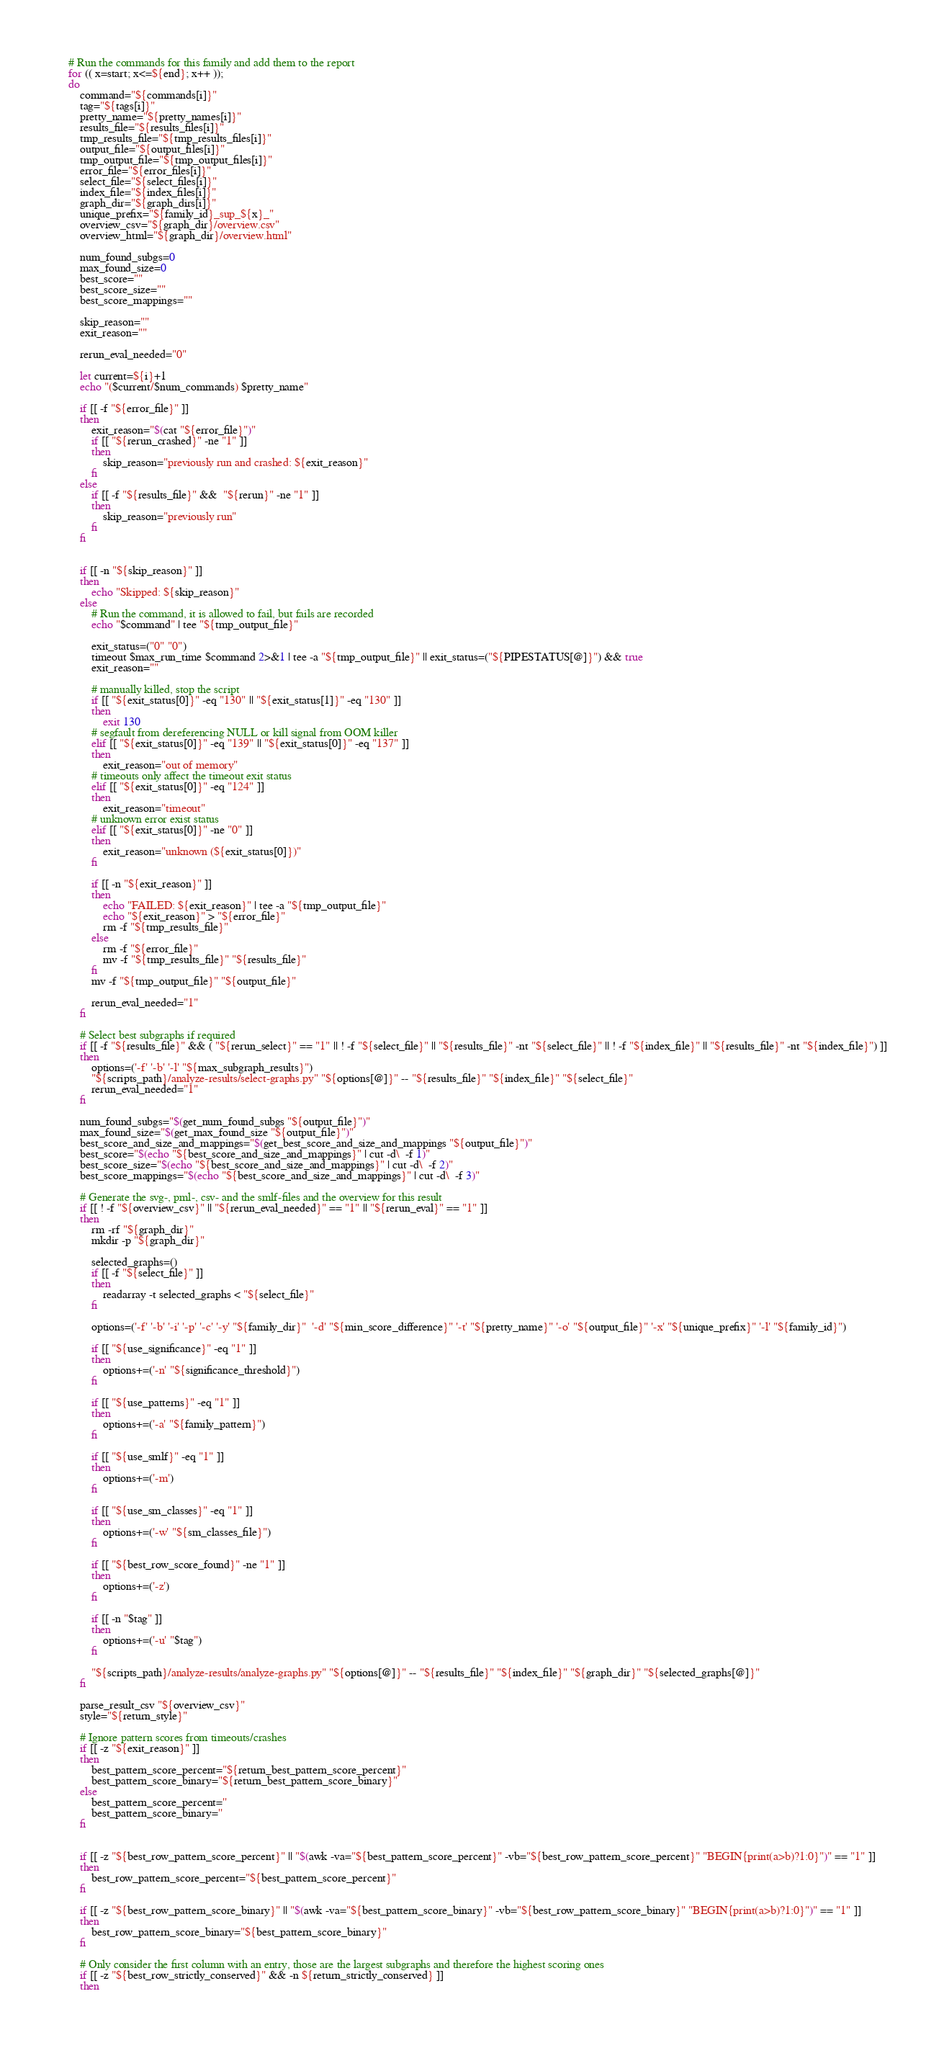Convert code to text. <code><loc_0><loc_0><loc_500><loc_500><_Bash_>    # Run the commands for this family and add them to the report
    for (( x=start; x<=${end}; x++ ));
    do
        command="${commands[i]}"
        tag="${tags[i]}"
        pretty_name="${pretty_names[i]}"
        results_file="${results_files[i]}"
        tmp_results_file="${tmp_results_files[i]}"
        output_file="${output_files[i]}"
        tmp_output_file="${tmp_output_files[i]}"
        error_file="${error_files[i]}"
        select_file="${select_files[i]}"
        index_file="${index_files[i]}"
        graph_dir="${graph_dirs[i]}"
        unique_prefix="${family_id}_sup_${x}_"
        overview_csv="${graph_dir}/overview.csv"
        overview_html="${graph_dir}/overview.html"

        num_found_subgs=0
        max_found_size=0
        best_score=""
        best_score_size=""
        best_score_mappings=""

        skip_reason=""
        exit_reason=""

        rerun_eval_needed="0"

        let current=${i}+1
        echo "($current/$num_commands) $pretty_name"

        if [[ -f "${error_file}" ]]
        then
            exit_reason="$(cat "${error_file}")"
            if [[ "${rerun_crashed}" -ne "1" ]]
            then
                skip_reason="previously run and crashed: ${exit_reason}"
            fi
        else
            if [[ -f "${results_file}" &&  "${rerun}" -ne "1" ]]
            then
                skip_reason="previously run"
            fi
        fi


        if [[ -n "${skip_reason}" ]]
        then
            echo "Skipped: ${skip_reason}"
        else
            # Run the command, it is allowed to fail, but fails are recorded
            echo "$command" | tee "${tmp_output_file}"

            exit_status=("0" "0")
            timeout $max_run_time $command 2>&1 | tee -a "${tmp_output_file}" || exit_status=("${PIPESTATUS[@]}") && true
            exit_reason=""

            # manually killed, stop the script        
            if [[ "${exit_status[0]}" -eq "130" || "${exit_status[1]}" -eq "130" ]]
            then
                exit 130
            # segfault from dereferencing NULL or kill signal from OOM killer
            elif [[ "${exit_status[0]}" -eq "139" || "${exit_status[0]}" -eq "137" ]]
            then
                exit_reason="out of memory"
            # timeouts only affect the timeout exit status
            elif [[ "${exit_status[0]}" -eq "124" ]]
            then
                exit_reason="timeout"
            # unknown error exist status
            elif [[ "${exit_status[0]}" -ne "0" ]]
            then
                exit_reason="unknown (${exit_status[0]})"
            fi

            if [[ -n "${exit_reason}" ]]
            then
                echo "FAILED: ${exit_reason}" | tee -a "${tmp_output_file}"
                echo "${exit_reason}" > "${error_file}"
                rm -f "${tmp_results_file}"
            else
                rm -f "${error_file}"
                mv -f "${tmp_results_file}" "${results_file}"
            fi
            mv -f "${tmp_output_file}" "${output_file}"

            rerun_eval_needed="1"
        fi

        # Select best subgraphs if required
        if [[ -f "${results_file}" && ( "${rerun_select}" == "1" || ! -f "${select_file}" || "${results_file}" -nt "${select_file}" || ! -f "${index_file}" || "${results_file}" -nt "${index_file}") ]]
        then
            options=('-f' '-b' '-l' "${max_subgraph_results}")
            "${scripts_path}/analyze-results/select-graphs.py" "${options[@]}" -- "${results_file}" "${index_file}" "${select_file}"
            rerun_eval_needed="1"
        fi

        num_found_subgs="$(get_num_found_subgs "${output_file}")"
        max_found_size="$(get_max_found_size "${output_file}")"
        best_score_and_size_and_mappings="$(get_best_score_and_size_and_mappings "${output_file}")"
        best_score="$(echo "${best_score_and_size_and_mappings}" | cut -d\  -f 1)"
        best_score_size="$(echo "${best_score_and_size_and_mappings}" | cut -d\  -f 2)"
        best_score_mappings="$(echo "${best_score_and_size_and_mappings}" | cut -d\  -f 3)"

        # Generate the svg-, pml-, csv- and the smlf-files and the overview for this result
        if [[ ! -f "${overview_csv}" || "${rerun_eval_needed}" == "1" || "${rerun_eval}" == "1" ]]
        then
            rm -rf "${graph_dir}"
            mkdir -p "${graph_dir}"

            selected_graphs=()
            if [[ -f "${select_file}" ]]
            then
                readarray -t selected_graphs < "${select_file}"
            fi

            options=('-f' '-b' '-i' '-p' '-c' '-y' "${family_dir}"  '-d' "${min_score_difference}" '-t' "${pretty_name}" '-o' "${output_file}" '-x' "${unique_prefix}" '-l' "${family_id}")

            if [[ "${use_significance}" -eq "1" ]]
            then
                options+=('-n' "${significance_threshold}")
            fi

            if [[ "${use_patterns}" -eq "1" ]]
            then
                options+=('-a' "${family_pattern}")
            fi

            if [[ "${use_smlf}" -eq "1" ]]
            then
                options+=('-m')
            fi

            if [[ "${use_sm_classes}" -eq "1" ]]
            then
                options+=('-w' "${sm_classes_file}")
            fi

            if [[ "${best_row_score_found}" -ne "1" ]]
            then
                options+=('-z')
            fi

            if [[ -n "$tag" ]]
            then
                options+=('-u' "$tag")
            fi

            "${scripts_path}/analyze-results/analyze-graphs.py" "${options[@]}" -- "${results_file}" "${index_file}" "${graph_dir}" "${selected_graphs[@]}"
        fi

        parse_result_csv "${overview_csv}"
        style="${return_style}"

        # Ignore pattern scores from timeouts/crashes
        if [[ -z "${exit_reason}" ]]
        then
            best_pattern_score_percent="${return_best_pattern_score_percent}"
            best_pattern_score_binary="${return_best_pattern_score_binary}"
        else
            best_pattern_score_percent=''
            best_pattern_score_binary=''
        fi


        if [[ -z "${best_row_pattern_score_percent}" || "$(awk -va="${best_pattern_score_percent}" -vb="${best_row_pattern_score_percent}" "BEGIN{print(a>b)?1:0}")" == "1" ]]
        then
            best_row_pattern_score_percent="${best_pattern_score_percent}"
        fi

        if [[ -z "${best_row_pattern_score_binary}" || "$(awk -va="${best_pattern_score_binary}" -vb="${best_row_pattern_score_binary}" "BEGIN{print(a>b)?1:0}")" == "1" ]]
        then
            best_row_pattern_score_binary="${best_pattern_score_binary}"
        fi

        # Only consider the first column with an entry, those are the largest subgraphs and therefore the highest scoring ones
        if [[ -z "${best_row_strictly_conserved}" && -n ${return_strictly_conserved} ]]
        then</code> 